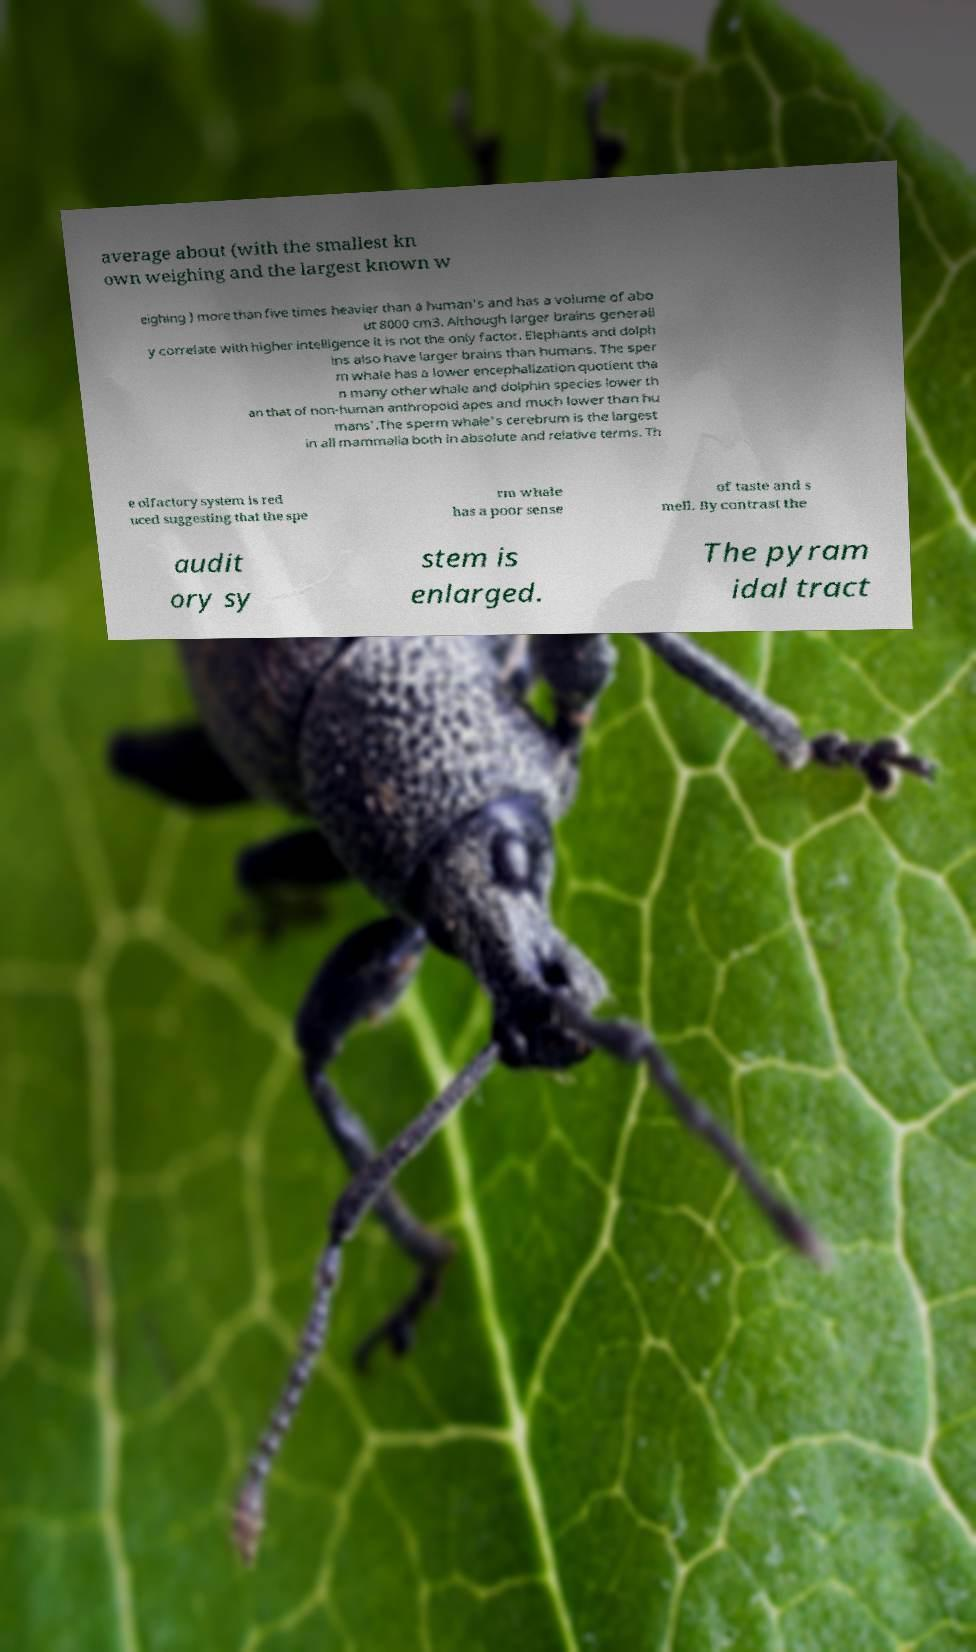Could you extract and type out the text from this image? average about (with the smallest kn own weighing and the largest known w eighing ) more than five times heavier than a human's and has a volume of abo ut 8000 cm3. Although larger brains generall y correlate with higher intelligence it is not the only factor. Elephants and dolph ins also have larger brains than humans. The sper m whale has a lower encephalization quotient tha n many other whale and dolphin species lower th an that of non-human anthropoid apes and much lower than hu mans'.The sperm whale's cerebrum is the largest in all mammalia both in absolute and relative terms. Th e olfactory system is red uced suggesting that the spe rm whale has a poor sense of taste and s mell. By contrast the audit ory sy stem is enlarged. The pyram idal tract 